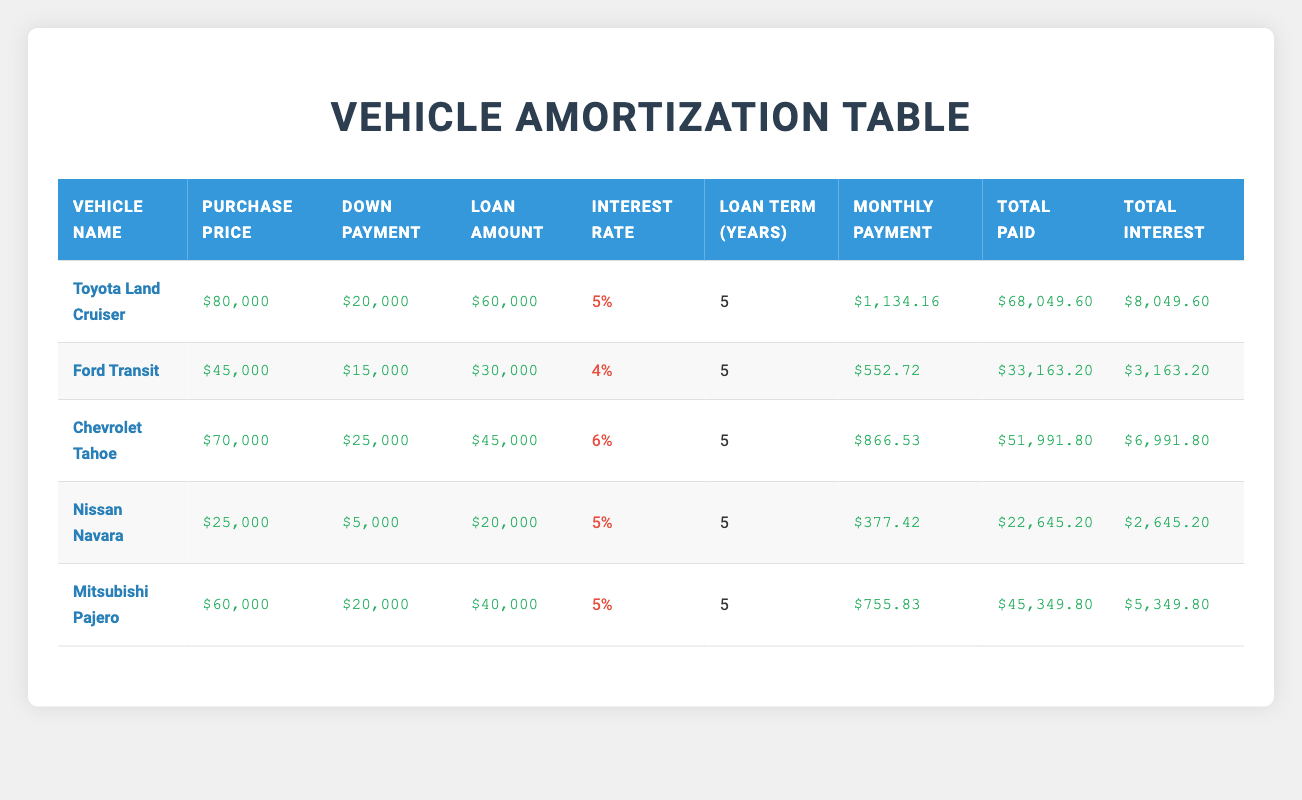What is the total purchase price of the Toyota Land Cruiser? The table lists the purchase price for the Toyota Land Cruiser as $80,000.
Answer: $80,000 What is the monthly payment for the Ford Transit? The table shows that the monthly payment for the Ford Transit is $552.72.
Answer: $552.72 Which vehicle has the highest total interest paid? The total interest paid for each vehicle is: Toyota Land Cruiser ($8,049.60), Ford Transit ($3,163.20), Chevrolet Tahoe ($6,991.80), Nissan Navara ($2,645.20), and Mitsubishi Pajero ($5,349.80). The Toyota Land Cruiser has the highest total interest paid at $8,049.60.
Answer: Toyota Land Cruiser What is the average loan amount across all vehicles? The loan amounts are: $60,000 (Toyota Land Cruiser), $30,000 (Ford Transit), $45,000 (Chevrolet Tahoe), $20,000 (Nissan Navara), and $40,000 (Mitsubishi Pajero). The total loan amount is $60,000 + $30,000 + $45,000 + $20,000 + $40,000 = $195,000. The average loan amount is $195,000 / 5 = $39,000.
Answer: $39,000 Is the total paid for the Chevrolet Tahoe greater than $50,000? The total paid for the Chevrolet Tahoe is $51,991.80, which is greater than $50,000. Therefore, the statement is true.
Answer: Yes What is the difference in total paid between the Nissan Navara and the Mitsubishi Pajero? The total paid for the Nissan Navara is $22,645.20, and for the Mitsubishi Pajero, it is $45,349.80. The difference is $45,349.80 - $22,645.20 = $22,704.60.
Answer: $22,704.60 Which vehicle has the lowest interest rate, and what is that rate? The interest rates for the vehicles are 5% (Toyota Land Cruiser), 4% (Ford Transit), 6% (Chevrolet Tahoe), 5% (Nissan Navara), and 5% (Mitsubishi Pajero). The Ford Transit has the lowest interest rate at 4%.
Answer: Ford Transit, 4% If you combine the down payments for all vehicles, what is the total amount? The down payments for the vehicles are $20,000 (Toyota Land Cruiser), $15,000 (Ford Transit), $25,000 (Chevrolet Tahoe), $5,000 (Nissan Navara), and $20,000 (Mitsubishi Pajero). The total down payment is $20,000 + $15,000 + $25,000 + $5,000 + $20,000 = $85,000.
Answer: $85,000 What percentage of the purchase price is the total interest on the Ford Transit? The total interest for the Ford Transit is $3,163.20, and the purchase price is $45,000. To find the percentage: (3,163.20 / 45,000) * 100 = 7.02%.
Answer: 7.02% 